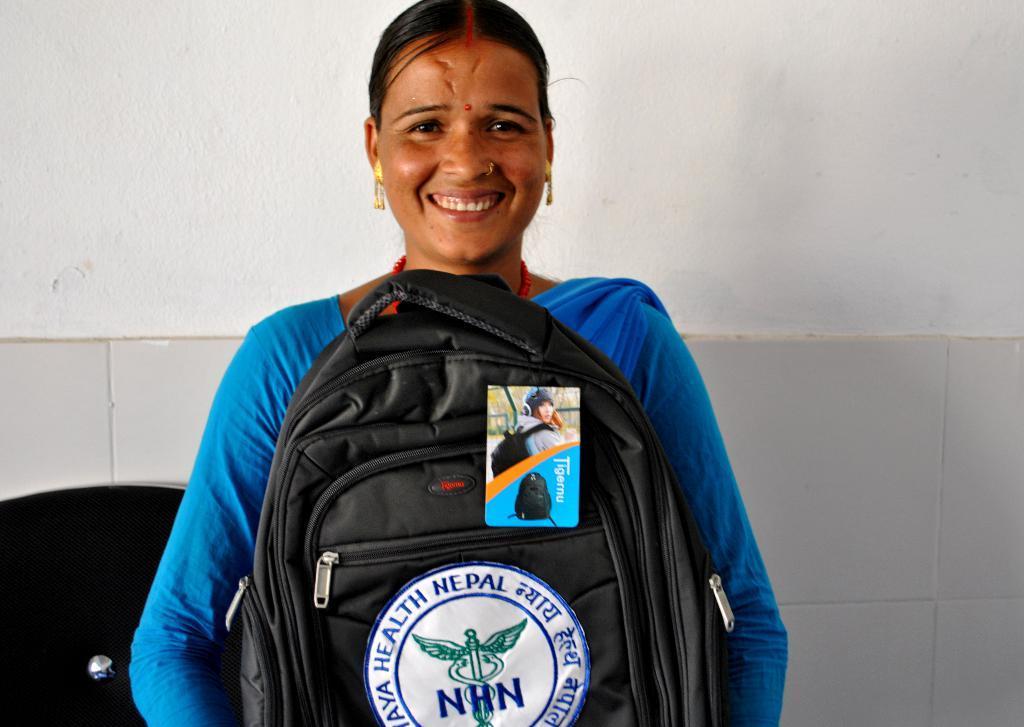Can you describe this image briefly? There is a woman holding a bag with a smile on her face. She is in blue color dress. Behind her there is a wall in the background. 